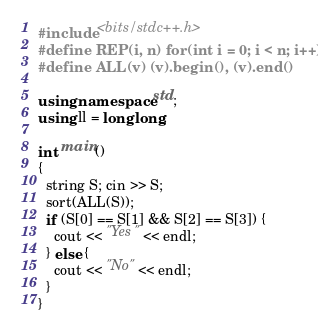Convert code to text. <code><loc_0><loc_0><loc_500><loc_500><_C++_>#include <bits/stdc++.h>
#define REP(i, n) for(int i = 0; i < n; i++)
#define ALL(v) (v).begin(), (v).end()

using namespace std;
using ll = long long;

int main()
{
  string S; cin >> S;
  sort(ALL(S));
  if (S[0] == S[1] && S[2] == S[3]) {
    cout << "Yes" << endl;
  } else {
    cout << "No" << endl;
  }
}</code> 